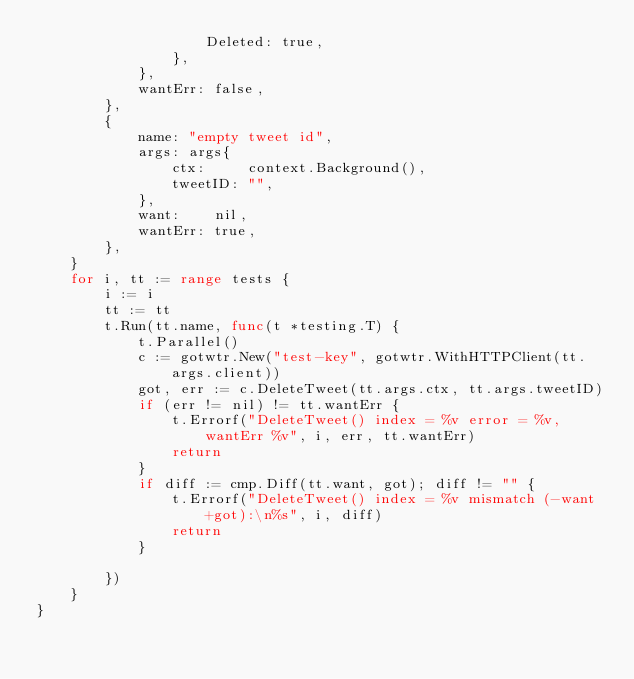Convert code to text. <code><loc_0><loc_0><loc_500><loc_500><_Go_>					Deleted: true,
				},
			},
			wantErr: false,
		},
		{
			name: "empty tweet id",
			args: args{
				ctx:     context.Background(),
				tweetID: "",
			},
			want:    nil,
			wantErr: true,
		},
	}
	for i, tt := range tests {
		i := i
		tt := tt
		t.Run(tt.name, func(t *testing.T) {
			t.Parallel()
			c := gotwtr.New("test-key", gotwtr.WithHTTPClient(tt.args.client))
			got, err := c.DeleteTweet(tt.args.ctx, tt.args.tweetID)
			if (err != nil) != tt.wantErr {
				t.Errorf("DeleteTweet() index = %v error = %v, wantErr %v", i, err, tt.wantErr)
				return
			}
			if diff := cmp.Diff(tt.want, got); diff != "" {
				t.Errorf("DeleteTweet() index = %v mismatch (-want +got):\n%s", i, diff)
				return
			}

		})
	}
}
</code> 